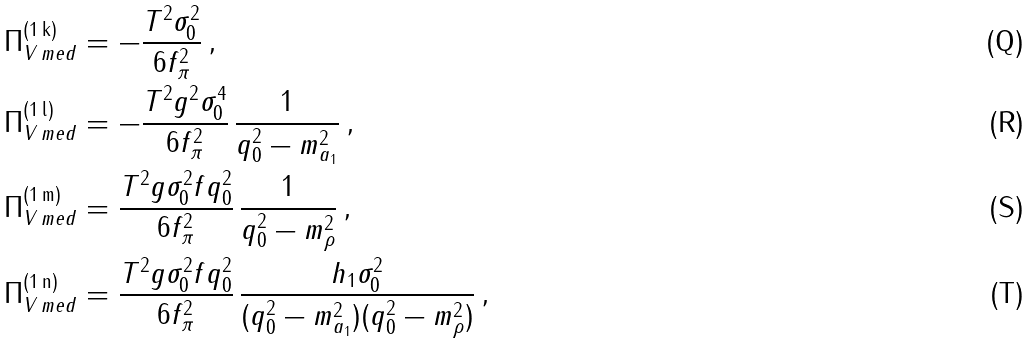<formula> <loc_0><loc_0><loc_500><loc_500>\Pi _ { V \, m e d } ^ { ( 1 \, \text {k} ) } & = - \frac { T ^ { 2 } \sigma _ { 0 } ^ { 2 } } { 6 f _ { \pi } ^ { 2 } } \, , \\ \Pi _ { V \, m e d } ^ { ( 1 \, \text {l} ) } & = - \frac { T ^ { 2 } g ^ { 2 } \sigma _ { 0 } ^ { 4 } } { 6 f _ { \pi } ^ { 2 } } \, \frac { 1 } { q _ { 0 } ^ { 2 } - m _ { a _ { 1 } } ^ { 2 } } \, , \\ \Pi _ { V \, m e d } ^ { ( 1 \, \text {m} ) } & = \frac { T ^ { 2 } g \sigma _ { 0 } ^ { 2 } f q _ { 0 } ^ { 2 } } { 6 f _ { \pi } ^ { 2 } } \, \frac { 1 } { q _ { 0 } ^ { 2 } - m _ { \rho } ^ { 2 } } \, , \\ \Pi _ { V \, m e d } ^ { ( 1 \, \text {n} ) } & = \frac { T ^ { 2 } g \sigma _ { 0 } ^ { 2 } f q _ { 0 } ^ { 2 } } { 6 f _ { \pi } ^ { 2 } } \, \frac { h _ { 1 } \sigma _ { 0 } ^ { 2 } } { ( q _ { 0 } ^ { 2 } - m _ { a _ { 1 } } ^ { 2 } ) ( q _ { 0 } ^ { 2 } - m _ { \rho } ^ { 2 } ) } \, ,</formula> 